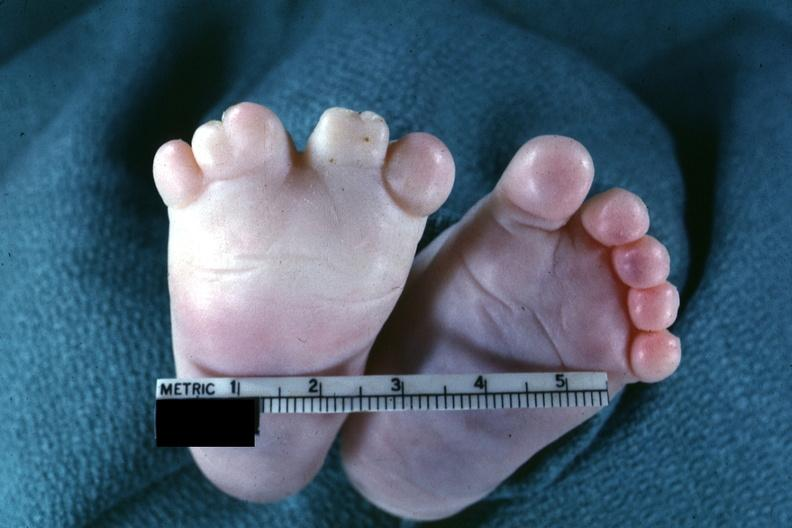s feet present?
Answer the question using a single word or phrase. Yes 